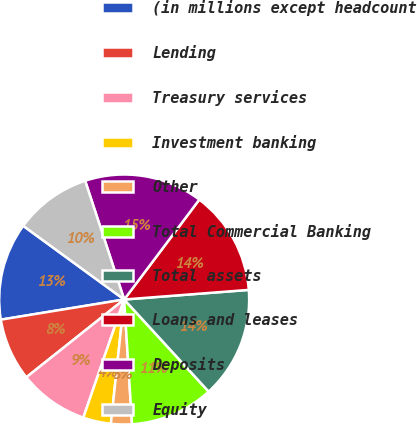Convert chart to OTSL. <chart><loc_0><loc_0><loc_500><loc_500><pie_chart><fcel>(in millions except headcount<fcel>Lending<fcel>Treasury services<fcel>Investment banking<fcel>Other<fcel>Total Commercial Banking<fcel>Total assets<fcel>Loans and leases<fcel>Deposits<fcel>Equity<nl><fcel>12.61%<fcel>8.11%<fcel>9.01%<fcel>3.6%<fcel>2.7%<fcel>10.81%<fcel>14.41%<fcel>13.51%<fcel>15.32%<fcel>9.91%<nl></chart> 